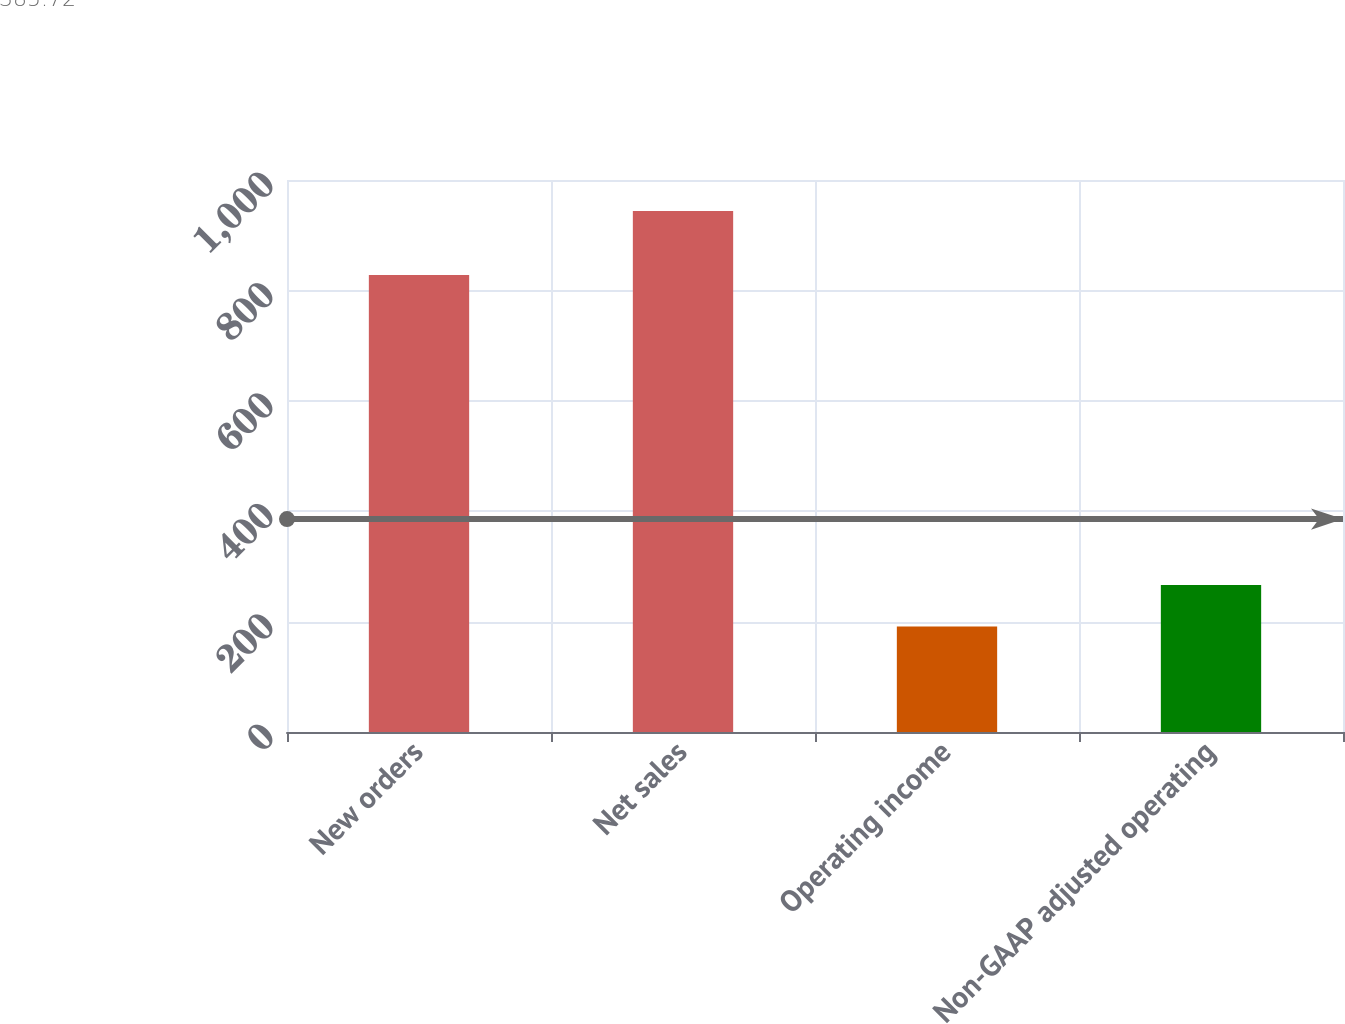Convert chart to OTSL. <chart><loc_0><loc_0><loc_500><loc_500><bar_chart><fcel>New orders<fcel>Net sales<fcel>Operating income<fcel>Non-GAAP adjusted operating<nl><fcel>828<fcel>944<fcel>191<fcel>266.3<nl></chart> 